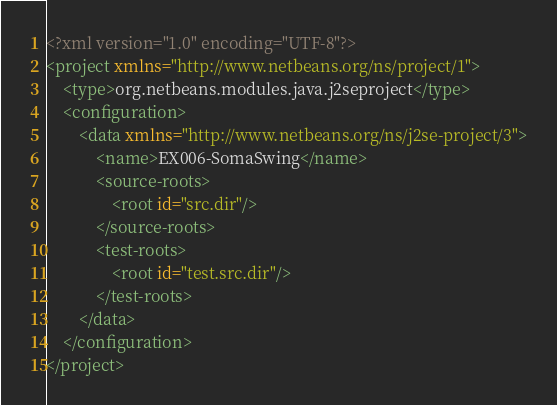<code> <loc_0><loc_0><loc_500><loc_500><_XML_><?xml version="1.0" encoding="UTF-8"?>
<project xmlns="http://www.netbeans.org/ns/project/1">
    <type>org.netbeans.modules.java.j2seproject</type>
    <configuration>
        <data xmlns="http://www.netbeans.org/ns/j2se-project/3">
            <name>EX006-SomaSwing</name>
            <source-roots>
                <root id="src.dir"/>
            </source-roots>
            <test-roots>
                <root id="test.src.dir"/>
            </test-roots>
        </data>
    </configuration>
</project>
</code> 